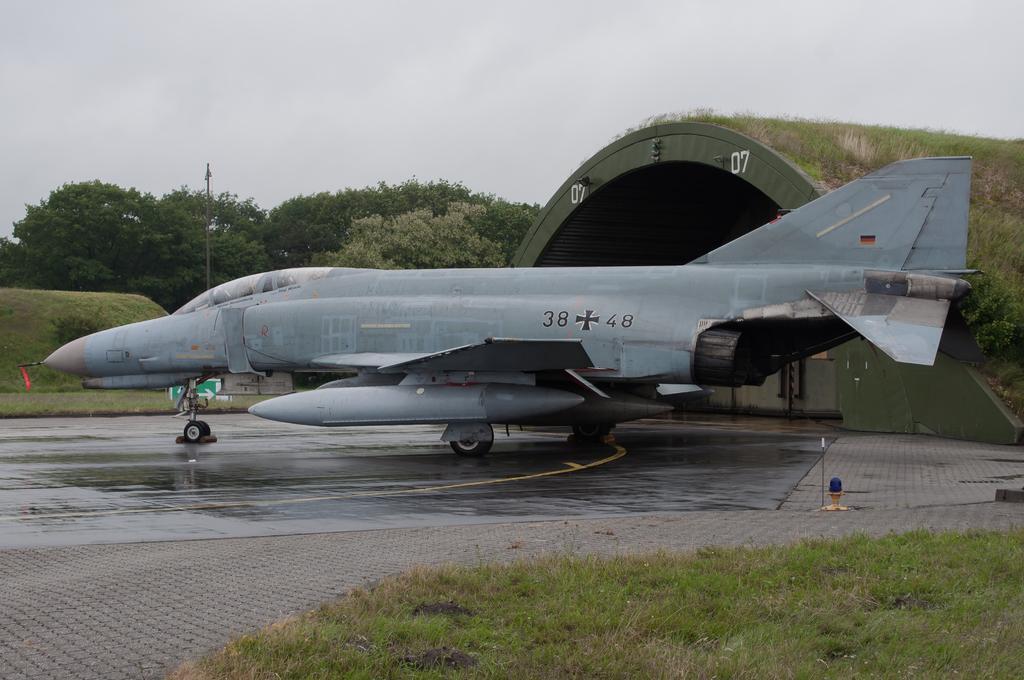Can you describe this image briefly? In the image there is a flight on the ground. At the bottom of the image on the ground there is grass. Behind the flight there is an arch shaped shed with grass on it. In the background there are trees and also there is a pole. At the top of the image there is sky. 